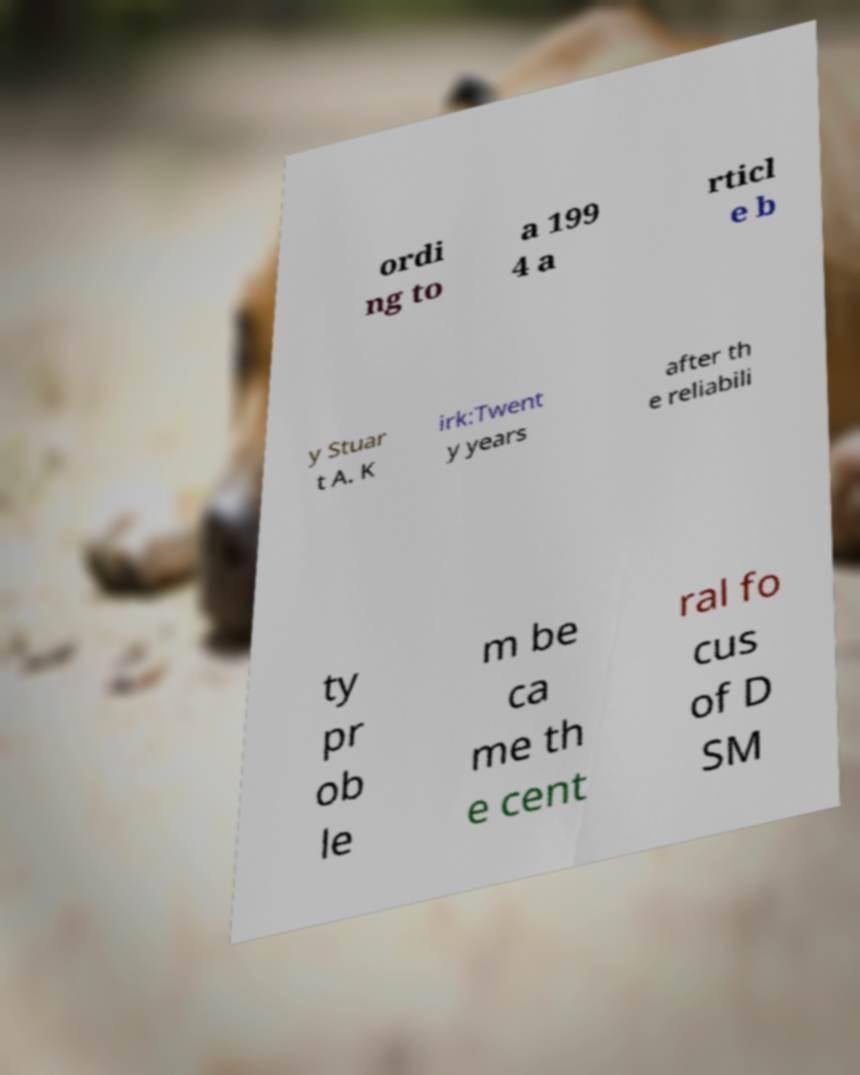I need the written content from this picture converted into text. Can you do that? ordi ng to a 199 4 a rticl e b y Stuar t A. K irk:Twent y years after th e reliabili ty pr ob le m be ca me th e cent ral fo cus of D SM 